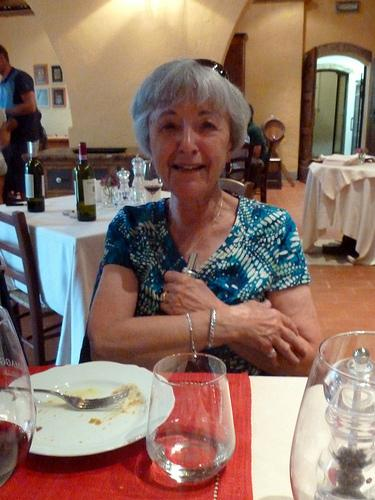Analyze the mood or atmosphere portrayed in this image. The scene portrays a calm, relaxed atmosphere, as the woman is casually sitting at a table with a meal and a glass of wine. Please describe the woman's appearance in detail. The woman has gray hair, sunglasses on her head, hoop earrings, a blue and white shirt, silver bracelets on her wrist, and a ring on her finger. How many types of jewelry and accessories does the woman have? The woman has 5 types of jewelry and accessories: sunglasses, hoop earrings, silver bracelets, ring, and a blue and white shirt. What is unique about the woman's hair in this picture? The woman's hair is gray which indicates she might be an elderly or middle-aged person. Can you tell me what's taking place at this scene? A woman is sitting at a table with wine, a plate, fork, and glass; she has sunglasses on her head, gray hair, hoop earrings, silver bracelets, and a blue and white shirt. Provide a brief description of the table setting in this image. The table is set with a white plate, silver fork, empty clear glass, red place mat, and a bottle of wine. List all the objects on the table in this image. White plate, silver fork, clear glass, red place mat, bottle of wine, edge of a cup, part of a fork, and a pepper cracker. Identify the type of floor and wall surfaces in this scene. The floor appears to have a red brick surface, and the wall has a yellow stucco surface. 